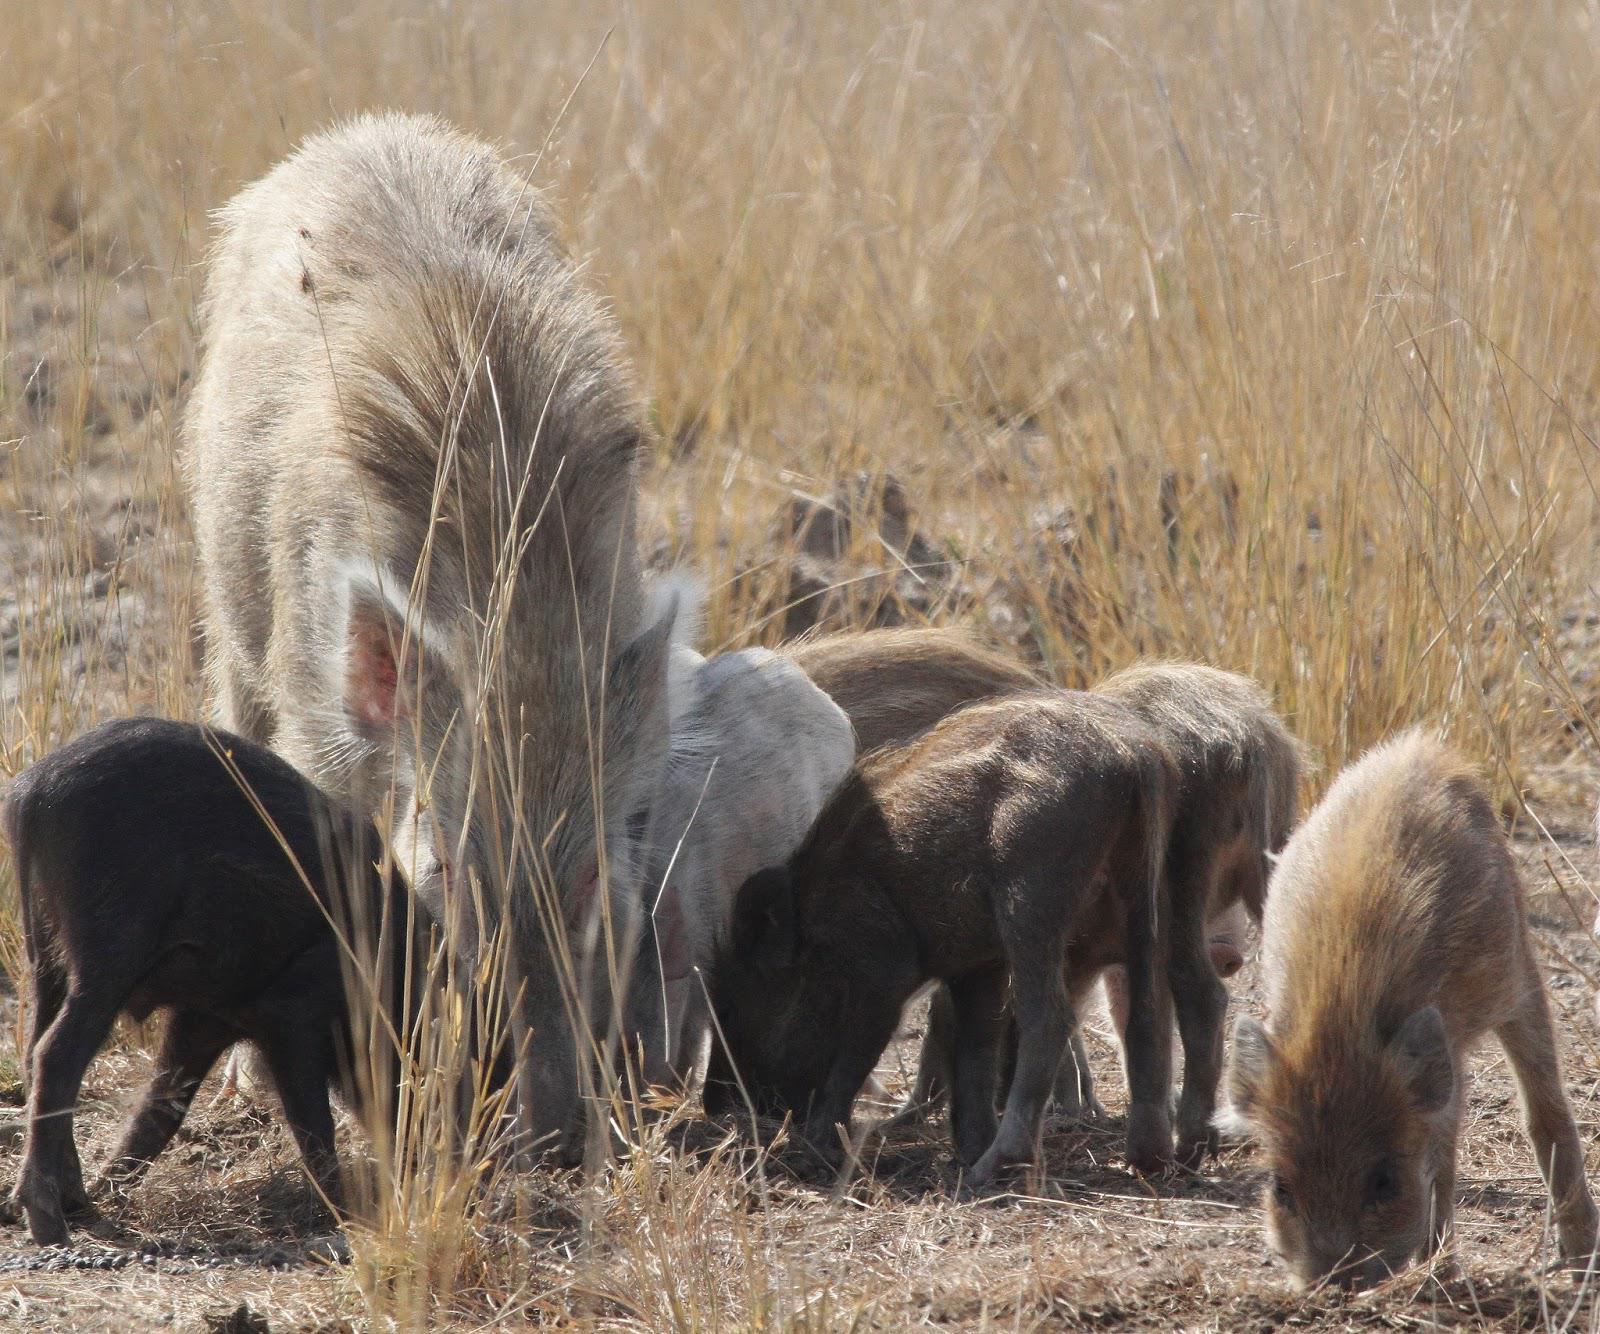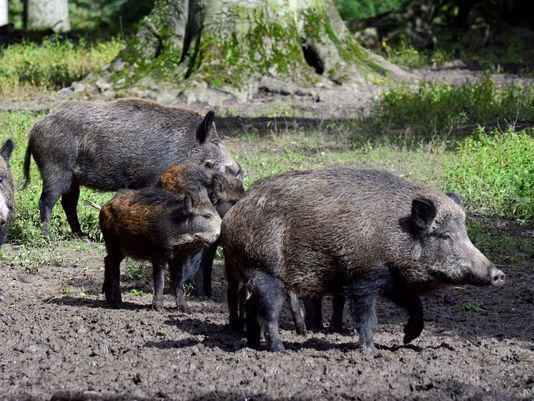The first image is the image on the left, the second image is the image on the right. For the images shown, is this caption "One image contains no more than 4 pigs." true? Answer yes or no. Yes. The first image is the image on the left, the second image is the image on the right. Examine the images to the left and right. Is the description "One of the images shows only 4 animals." accurate? Answer yes or no. Yes. 